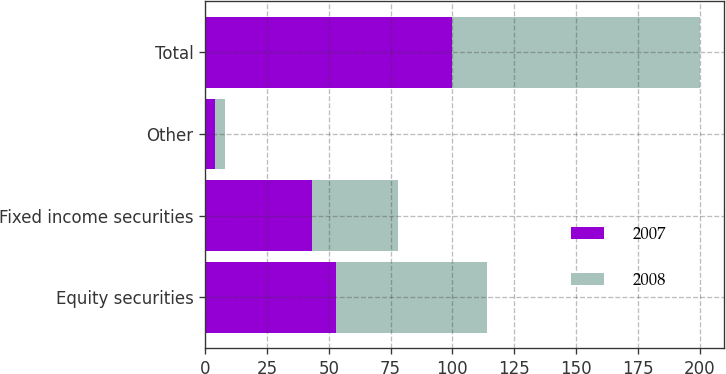Convert chart to OTSL. <chart><loc_0><loc_0><loc_500><loc_500><stacked_bar_chart><ecel><fcel>Equity securities<fcel>Fixed income securities<fcel>Other<fcel>Total<nl><fcel>2007<fcel>53<fcel>43<fcel>4<fcel>100<nl><fcel>2008<fcel>61<fcel>35<fcel>4<fcel>100<nl></chart> 